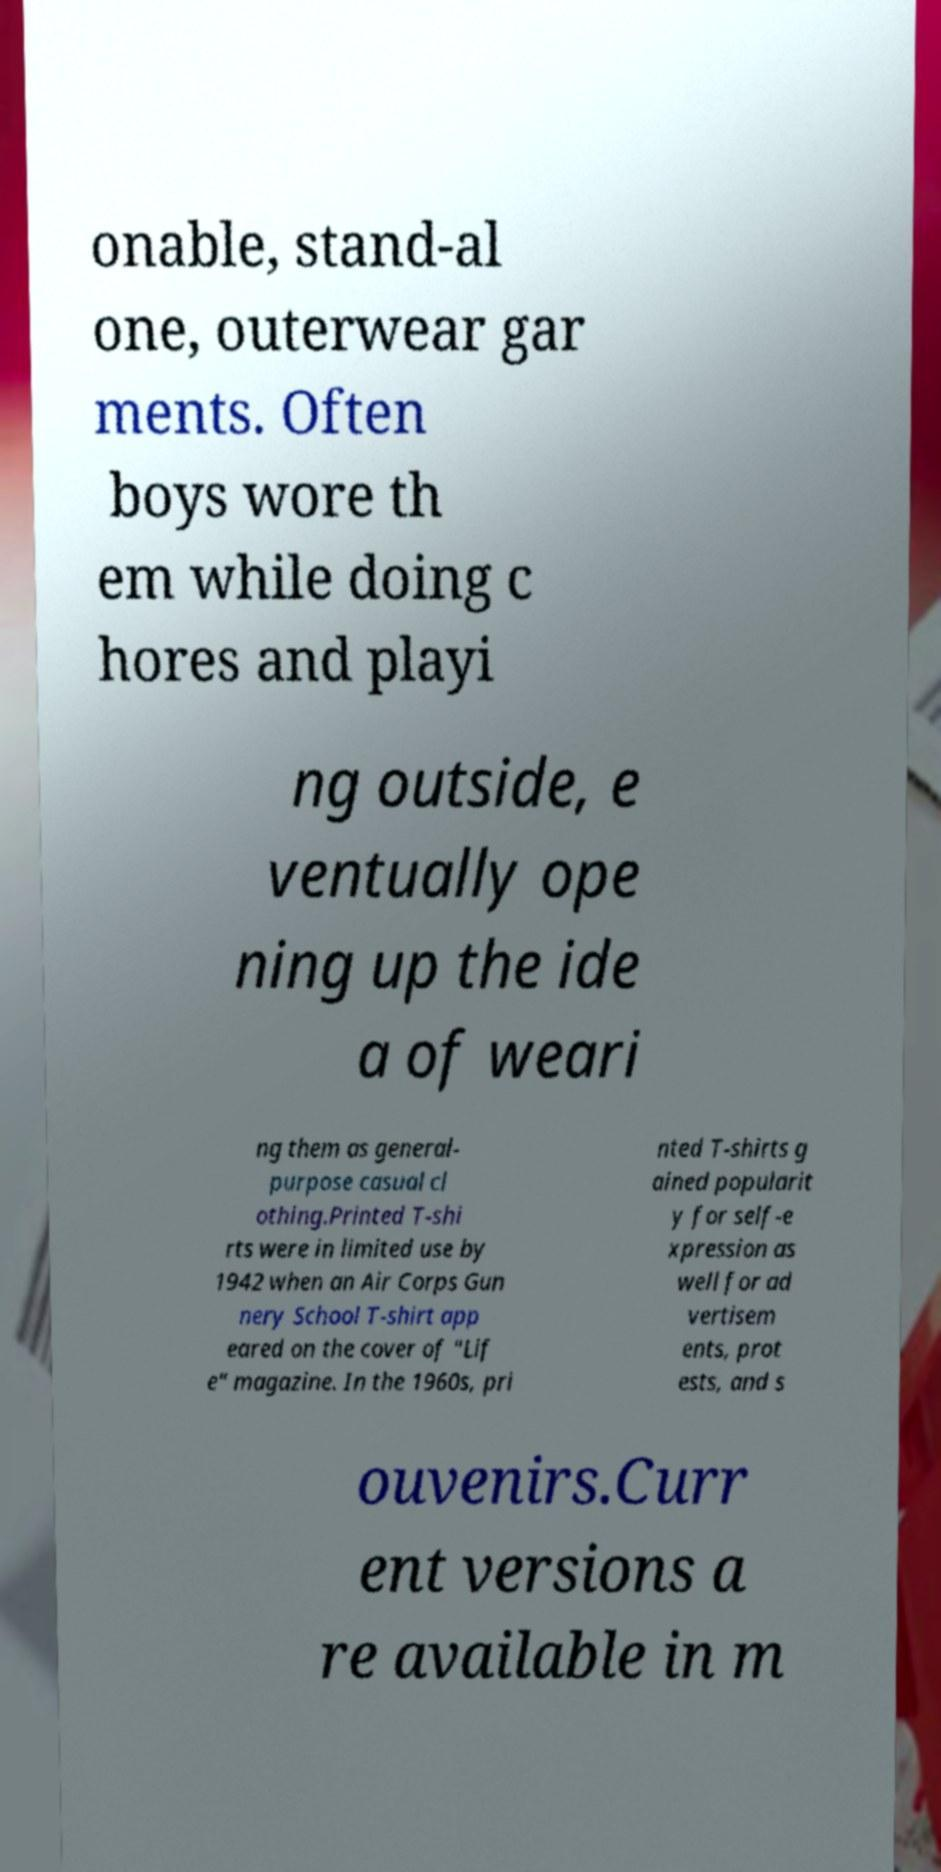Could you extract and type out the text from this image? onable, stand-al one, outerwear gar ments. Often boys wore th em while doing c hores and playi ng outside, e ventually ope ning up the ide a of weari ng them as general- purpose casual cl othing.Printed T-shi rts were in limited use by 1942 when an Air Corps Gun nery School T-shirt app eared on the cover of "Lif e" magazine. In the 1960s, pri nted T-shirts g ained popularit y for self-e xpression as well for ad vertisem ents, prot ests, and s ouvenirs.Curr ent versions a re available in m 